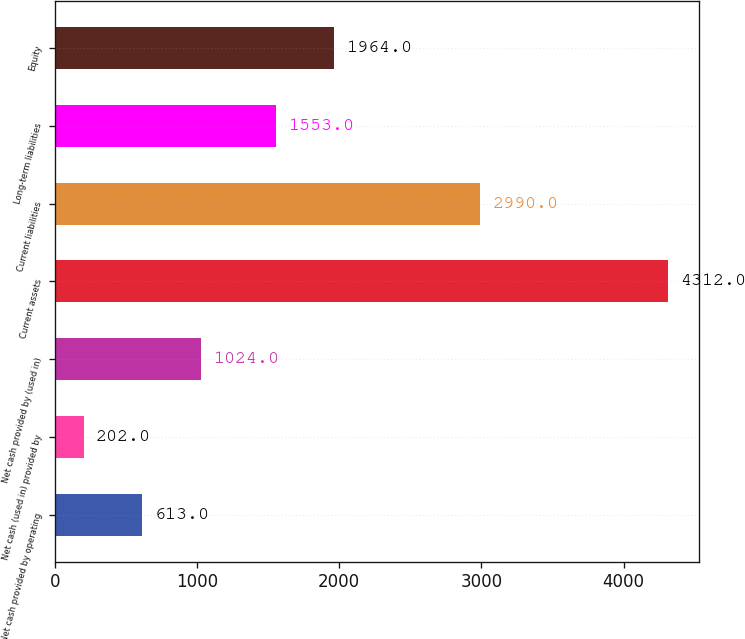Convert chart. <chart><loc_0><loc_0><loc_500><loc_500><bar_chart><fcel>Net cash provided by operating<fcel>Net cash (used in) provided by<fcel>Net cash provided by (used in)<fcel>Current assets<fcel>Current liabilities<fcel>Long-term liabilities<fcel>Equity<nl><fcel>613<fcel>202<fcel>1024<fcel>4312<fcel>2990<fcel>1553<fcel>1964<nl></chart> 